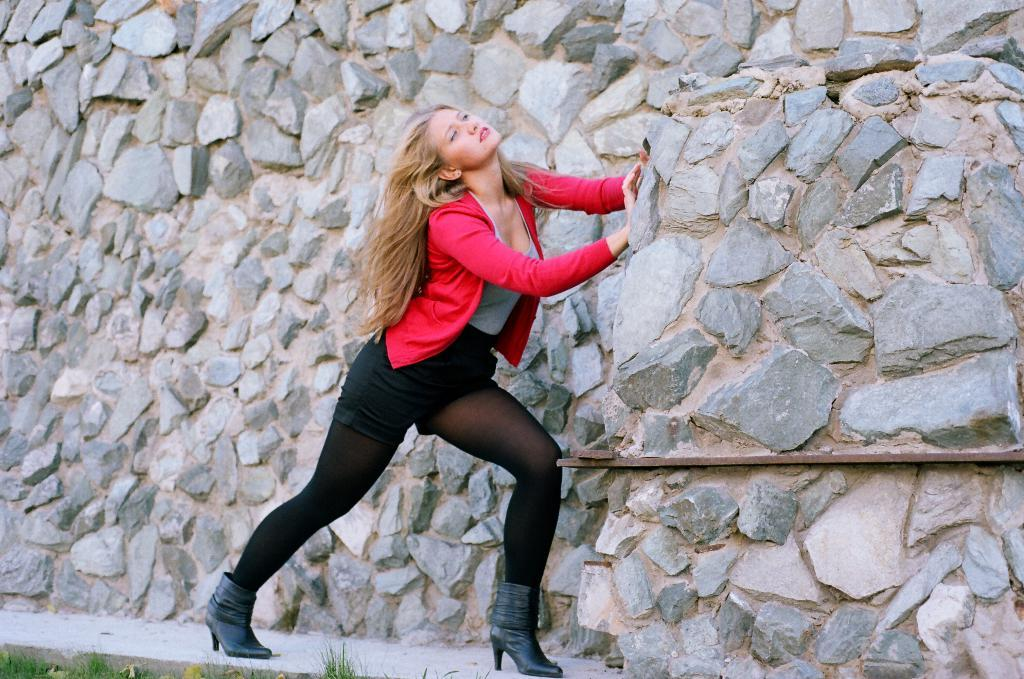What is the main subject of the image? There is a person standing in the image. What type of natural environment is visible in the image? There is grass visible in the image. How is the grass depicted in the image? The grass is truncated towards the bottom of the image. What type of structure is visible in the image? There is a wall visible in the image. How is the wall depicted in the image? The wall is truncated. What type of ink is being used to write on the grass in the image? There is no ink or writing present on the grass in the image. 